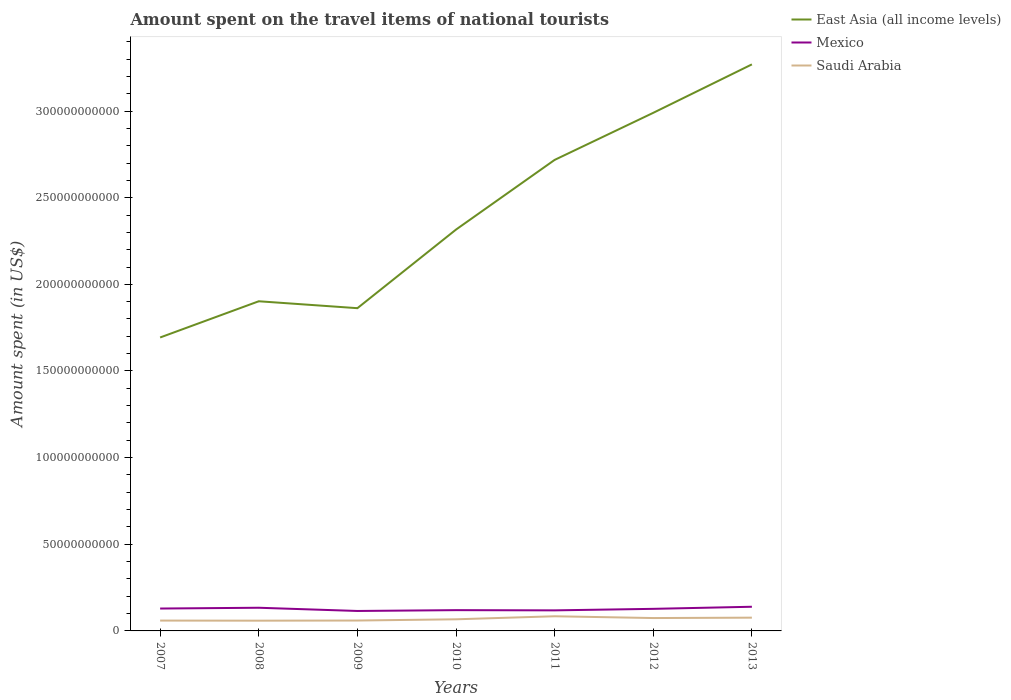How many different coloured lines are there?
Make the answer very short. 3. Across all years, what is the maximum amount spent on the travel items of national tourists in Saudi Arabia?
Offer a very short reply. 5.91e+09. In which year was the amount spent on the travel items of national tourists in East Asia (all income levels) maximum?
Provide a short and direct response. 2007. What is the total amount spent on the travel items of national tourists in Saudi Arabia in the graph?
Make the answer very short. 1.03e+09. What is the difference between the highest and the second highest amount spent on the travel items of national tourists in East Asia (all income levels)?
Ensure brevity in your answer.  1.58e+11. Is the amount spent on the travel items of national tourists in Saudi Arabia strictly greater than the amount spent on the travel items of national tourists in East Asia (all income levels) over the years?
Offer a terse response. Yes. How many lines are there?
Your response must be concise. 3. Where does the legend appear in the graph?
Your response must be concise. Top right. How many legend labels are there?
Ensure brevity in your answer.  3. How are the legend labels stacked?
Your answer should be compact. Vertical. What is the title of the graph?
Give a very brief answer. Amount spent on the travel items of national tourists. Does "Zimbabwe" appear as one of the legend labels in the graph?
Offer a very short reply. No. What is the label or title of the X-axis?
Your answer should be compact. Years. What is the label or title of the Y-axis?
Offer a terse response. Amount spent (in US$). What is the Amount spent (in US$) in East Asia (all income levels) in 2007?
Keep it short and to the point. 1.69e+11. What is the Amount spent (in US$) in Mexico in 2007?
Provide a succinct answer. 1.29e+1. What is the Amount spent (in US$) of Saudi Arabia in 2007?
Make the answer very short. 5.97e+09. What is the Amount spent (in US$) of East Asia (all income levels) in 2008?
Make the answer very short. 1.90e+11. What is the Amount spent (in US$) of Mexico in 2008?
Your answer should be very brief. 1.34e+1. What is the Amount spent (in US$) of Saudi Arabia in 2008?
Your response must be concise. 5.91e+09. What is the Amount spent (in US$) in East Asia (all income levels) in 2009?
Offer a very short reply. 1.86e+11. What is the Amount spent (in US$) of Mexico in 2009?
Make the answer very short. 1.15e+1. What is the Amount spent (in US$) of Saudi Arabia in 2009?
Provide a short and direct response. 6.00e+09. What is the Amount spent (in US$) of East Asia (all income levels) in 2010?
Your response must be concise. 2.32e+11. What is the Amount spent (in US$) of Mexico in 2010?
Your answer should be compact. 1.20e+1. What is the Amount spent (in US$) of Saudi Arabia in 2010?
Make the answer very short. 6.71e+09. What is the Amount spent (in US$) in East Asia (all income levels) in 2011?
Offer a very short reply. 2.72e+11. What is the Amount spent (in US$) in Mexico in 2011?
Give a very brief answer. 1.19e+1. What is the Amount spent (in US$) in Saudi Arabia in 2011?
Ensure brevity in your answer.  8.46e+09. What is the Amount spent (in US$) in East Asia (all income levels) in 2012?
Offer a very short reply. 2.99e+11. What is the Amount spent (in US$) of Mexico in 2012?
Your response must be concise. 1.27e+1. What is the Amount spent (in US$) of Saudi Arabia in 2012?
Ensure brevity in your answer.  7.43e+09. What is the Amount spent (in US$) of East Asia (all income levels) in 2013?
Provide a short and direct response. 3.27e+11. What is the Amount spent (in US$) of Mexico in 2013?
Your answer should be compact. 1.39e+1. What is the Amount spent (in US$) in Saudi Arabia in 2013?
Keep it short and to the point. 7.65e+09. Across all years, what is the maximum Amount spent (in US$) of East Asia (all income levels)?
Ensure brevity in your answer.  3.27e+11. Across all years, what is the maximum Amount spent (in US$) of Mexico?
Offer a terse response. 1.39e+1. Across all years, what is the maximum Amount spent (in US$) in Saudi Arabia?
Your answer should be compact. 8.46e+09. Across all years, what is the minimum Amount spent (in US$) of East Asia (all income levels)?
Make the answer very short. 1.69e+11. Across all years, what is the minimum Amount spent (in US$) of Mexico?
Give a very brief answer. 1.15e+1. Across all years, what is the minimum Amount spent (in US$) of Saudi Arabia?
Provide a succinct answer. 5.91e+09. What is the total Amount spent (in US$) in East Asia (all income levels) in the graph?
Offer a terse response. 1.68e+12. What is the total Amount spent (in US$) of Mexico in the graph?
Provide a succinct answer. 8.84e+1. What is the total Amount spent (in US$) of Saudi Arabia in the graph?
Offer a terse response. 4.81e+1. What is the difference between the Amount spent (in US$) of East Asia (all income levels) in 2007 and that in 2008?
Keep it short and to the point. -2.09e+1. What is the difference between the Amount spent (in US$) in Mexico in 2007 and that in 2008?
Provide a succinct answer. -4.51e+08. What is the difference between the Amount spent (in US$) of Saudi Arabia in 2007 and that in 2008?
Give a very brief answer. 6.10e+07. What is the difference between the Amount spent (in US$) of East Asia (all income levels) in 2007 and that in 2009?
Offer a very short reply. -1.69e+1. What is the difference between the Amount spent (in US$) of Mexico in 2007 and that in 2009?
Provide a short and direct response. 1.41e+09. What is the difference between the Amount spent (in US$) in Saudi Arabia in 2007 and that in 2009?
Offer a terse response. -2.40e+07. What is the difference between the Amount spent (in US$) of East Asia (all income levels) in 2007 and that in 2010?
Make the answer very short. -6.23e+1. What is the difference between the Amount spent (in US$) in Mexico in 2007 and that in 2010?
Ensure brevity in your answer.  9.27e+08. What is the difference between the Amount spent (in US$) in Saudi Arabia in 2007 and that in 2010?
Your answer should be compact. -7.41e+08. What is the difference between the Amount spent (in US$) in East Asia (all income levels) in 2007 and that in 2011?
Give a very brief answer. -1.02e+11. What is the difference between the Amount spent (in US$) in Mexico in 2007 and that in 2011?
Provide a succinct answer. 1.05e+09. What is the difference between the Amount spent (in US$) in Saudi Arabia in 2007 and that in 2011?
Your answer should be very brief. -2.49e+09. What is the difference between the Amount spent (in US$) of East Asia (all income levels) in 2007 and that in 2012?
Your answer should be very brief. -1.30e+11. What is the difference between the Amount spent (in US$) of Mexico in 2007 and that in 2012?
Give a very brief answer. 1.80e+08. What is the difference between the Amount spent (in US$) of Saudi Arabia in 2007 and that in 2012?
Offer a terse response. -1.46e+09. What is the difference between the Amount spent (in US$) of East Asia (all income levels) in 2007 and that in 2013?
Ensure brevity in your answer.  -1.58e+11. What is the difference between the Amount spent (in US$) of Mexico in 2007 and that in 2013?
Make the answer very short. -1.03e+09. What is the difference between the Amount spent (in US$) in Saudi Arabia in 2007 and that in 2013?
Make the answer very short. -1.68e+09. What is the difference between the Amount spent (in US$) of East Asia (all income levels) in 2008 and that in 2009?
Offer a terse response. 3.99e+09. What is the difference between the Amount spent (in US$) of Mexico in 2008 and that in 2009?
Make the answer very short. 1.86e+09. What is the difference between the Amount spent (in US$) in Saudi Arabia in 2008 and that in 2009?
Offer a very short reply. -8.50e+07. What is the difference between the Amount spent (in US$) in East Asia (all income levels) in 2008 and that in 2010?
Your answer should be compact. -4.14e+1. What is the difference between the Amount spent (in US$) in Mexico in 2008 and that in 2010?
Offer a terse response. 1.38e+09. What is the difference between the Amount spent (in US$) in Saudi Arabia in 2008 and that in 2010?
Provide a short and direct response. -8.02e+08. What is the difference between the Amount spent (in US$) of East Asia (all income levels) in 2008 and that in 2011?
Your response must be concise. -8.16e+1. What is the difference between the Amount spent (in US$) of Mexico in 2008 and that in 2011?
Give a very brief answer. 1.50e+09. What is the difference between the Amount spent (in US$) of Saudi Arabia in 2008 and that in 2011?
Offer a very short reply. -2.55e+09. What is the difference between the Amount spent (in US$) of East Asia (all income levels) in 2008 and that in 2012?
Offer a very short reply. -1.09e+11. What is the difference between the Amount spent (in US$) in Mexico in 2008 and that in 2012?
Keep it short and to the point. 6.31e+08. What is the difference between the Amount spent (in US$) in Saudi Arabia in 2008 and that in 2012?
Your response must be concise. -1.52e+09. What is the difference between the Amount spent (in US$) in East Asia (all income levels) in 2008 and that in 2013?
Make the answer very short. -1.37e+11. What is the difference between the Amount spent (in US$) in Mexico in 2008 and that in 2013?
Provide a short and direct response. -5.79e+08. What is the difference between the Amount spent (in US$) in Saudi Arabia in 2008 and that in 2013?
Your answer should be very brief. -1.74e+09. What is the difference between the Amount spent (in US$) in East Asia (all income levels) in 2009 and that in 2010?
Make the answer very short. -4.54e+1. What is the difference between the Amount spent (in US$) in Mexico in 2009 and that in 2010?
Make the answer very short. -4.79e+08. What is the difference between the Amount spent (in US$) of Saudi Arabia in 2009 and that in 2010?
Ensure brevity in your answer.  -7.17e+08. What is the difference between the Amount spent (in US$) of East Asia (all income levels) in 2009 and that in 2011?
Provide a succinct answer. -8.56e+1. What is the difference between the Amount spent (in US$) of Mexico in 2009 and that in 2011?
Keep it short and to the point. -3.56e+08. What is the difference between the Amount spent (in US$) of Saudi Arabia in 2009 and that in 2011?
Provide a short and direct response. -2.46e+09. What is the difference between the Amount spent (in US$) in East Asia (all income levels) in 2009 and that in 2012?
Provide a short and direct response. -1.13e+11. What is the difference between the Amount spent (in US$) in Mexico in 2009 and that in 2012?
Offer a terse response. -1.23e+09. What is the difference between the Amount spent (in US$) in Saudi Arabia in 2009 and that in 2012?
Ensure brevity in your answer.  -1.44e+09. What is the difference between the Amount spent (in US$) in East Asia (all income levels) in 2009 and that in 2013?
Offer a very short reply. -1.41e+11. What is the difference between the Amount spent (in US$) in Mexico in 2009 and that in 2013?
Ensure brevity in your answer.  -2.44e+09. What is the difference between the Amount spent (in US$) of Saudi Arabia in 2009 and that in 2013?
Ensure brevity in your answer.  -1.66e+09. What is the difference between the Amount spent (in US$) of East Asia (all income levels) in 2010 and that in 2011?
Provide a succinct answer. -4.02e+1. What is the difference between the Amount spent (in US$) of Mexico in 2010 and that in 2011?
Your answer should be very brief. 1.23e+08. What is the difference between the Amount spent (in US$) of Saudi Arabia in 2010 and that in 2011?
Provide a short and direct response. -1.75e+09. What is the difference between the Amount spent (in US$) in East Asia (all income levels) in 2010 and that in 2012?
Offer a very short reply. -6.74e+1. What is the difference between the Amount spent (in US$) in Mexico in 2010 and that in 2012?
Provide a succinct answer. -7.47e+08. What is the difference between the Amount spent (in US$) in Saudi Arabia in 2010 and that in 2012?
Your response must be concise. -7.20e+08. What is the difference between the Amount spent (in US$) of East Asia (all income levels) in 2010 and that in 2013?
Provide a short and direct response. -9.53e+1. What is the difference between the Amount spent (in US$) in Mexico in 2010 and that in 2013?
Make the answer very short. -1.96e+09. What is the difference between the Amount spent (in US$) in Saudi Arabia in 2010 and that in 2013?
Make the answer very short. -9.39e+08. What is the difference between the Amount spent (in US$) of East Asia (all income levels) in 2011 and that in 2012?
Offer a very short reply. -2.72e+1. What is the difference between the Amount spent (in US$) of Mexico in 2011 and that in 2012?
Provide a succinct answer. -8.70e+08. What is the difference between the Amount spent (in US$) in Saudi Arabia in 2011 and that in 2012?
Your response must be concise. 1.03e+09. What is the difference between the Amount spent (in US$) in East Asia (all income levels) in 2011 and that in 2013?
Ensure brevity in your answer.  -5.51e+1. What is the difference between the Amount spent (in US$) of Mexico in 2011 and that in 2013?
Ensure brevity in your answer.  -2.08e+09. What is the difference between the Amount spent (in US$) in Saudi Arabia in 2011 and that in 2013?
Your response must be concise. 8.08e+08. What is the difference between the Amount spent (in US$) of East Asia (all income levels) in 2012 and that in 2013?
Your answer should be compact. -2.79e+1. What is the difference between the Amount spent (in US$) in Mexico in 2012 and that in 2013?
Offer a terse response. -1.21e+09. What is the difference between the Amount spent (in US$) of Saudi Arabia in 2012 and that in 2013?
Your response must be concise. -2.19e+08. What is the difference between the Amount spent (in US$) in East Asia (all income levels) in 2007 and the Amount spent (in US$) in Mexico in 2008?
Make the answer very short. 1.56e+11. What is the difference between the Amount spent (in US$) in East Asia (all income levels) in 2007 and the Amount spent (in US$) in Saudi Arabia in 2008?
Keep it short and to the point. 1.63e+11. What is the difference between the Amount spent (in US$) of Mexico in 2007 and the Amount spent (in US$) of Saudi Arabia in 2008?
Ensure brevity in your answer.  7.01e+09. What is the difference between the Amount spent (in US$) in East Asia (all income levels) in 2007 and the Amount spent (in US$) in Mexico in 2009?
Your answer should be compact. 1.58e+11. What is the difference between the Amount spent (in US$) in East Asia (all income levels) in 2007 and the Amount spent (in US$) in Saudi Arabia in 2009?
Keep it short and to the point. 1.63e+11. What is the difference between the Amount spent (in US$) in Mexico in 2007 and the Amount spent (in US$) in Saudi Arabia in 2009?
Your answer should be very brief. 6.92e+09. What is the difference between the Amount spent (in US$) in East Asia (all income levels) in 2007 and the Amount spent (in US$) in Mexico in 2010?
Your answer should be very brief. 1.57e+11. What is the difference between the Amount spent (in US$) in East Asia (all income levels) in 2007 and the Amount spent (in US$) in Saudi Arabia in 2010?
Give a very brief answer. 1.63e+11. What is the difference between the Amount spent (in US$) in Mexico in 2007 and the Amount spent (in US$) in Saudi Arabia in 2010?
Give a very brief answer. 6.21e+09. What is the difference between the Amount spent (in US$) in East Asia (all income levels) in 2007 and the Amount spent (in US$) in Mexico in 2011?
Offer a terse response. 1.57e+11. What is the difference between the Amount spent (in US$) in East Asia (all income levels) in 2007 and the Amount spent (in US$) in Saudi Arabia in 2011?
Your answer should be very brief. 1.61e+11. What is the difference between the Amount spent (in US$) in Mexico in 2007 and the Amount spent (in US$) in Saudi Arabia in 2011?
Make the answer very short. 4.46e+09. What is the difference between the Amount spent (in US$) in East Asia (all income levels) in 2007 and the Amount spent (in US$) in Mexico in 2012?
Your answer should be very brief. 1.57e+11. What is the difference between the Amount spent (in US$) in East Asia (all income levels) in 2007 and the Amount spent (in US$) in Saudi Arabia in 2012?
Make the answer very short. 1.62e+11. What is the difference between the Amount spent (in US$) of Mexico in 2007 and the Amount spent (in US$) of Saudi Arabia in 2012?
Your response must be concise. 5.49e+09. What is the difference between the Amount spent (in US$) in East Asia (all income levels) in 2007 and the Amount spent (in US$) in Mexico in 2013?
Offer a very short reply. 1.55e+11. What is the difference between the Amount spent (in US$) of East Asia (all income levels) in 2007 and the Amount spent (in US$) of Saudi Arabia in 2013?
Your answer should be very brief. 1.62e+11. What is the difference between the Amount spent (in US$) of Mexico in 2007 and the Amount spent (in US$) of Saudi Arabia in 2013?
Keep it short and to the point. 5.27e+09. What is the difference between the Amount spent (in US$) of East Asia (all income levels) in 2008 and the Amount spent (in US$) of Mexico in 2009?
Give a very brief answer. 1.79e+11. What is the difference between the Amount spent (in US$) of East Asia (all income levels) in 2008 and the Amount spent (in US$) of Saudi Arabia in 2009?
Your answer should be compact. 1.84e+11. What is the difference between the Amount spent (in US$) of Mexico in 2008 and the Amount spent (in US$) of Saudi Arabia in 2009?
Keep it short and to the point. 7.38e+09. What is the difference between the Amount spent (in US$) in East Asia (all income levels) in 2008 and the Amount spent (in US$) in Mexico in 2010?
Offer a very short reply. 1.78e+11. What is the difference between the Amount spent (in US$) in East Asia (all income levels) in 2008 and the Amount spent (in US$) in Saudi Arabia in 2010?
Make the answer very short. 1.84e+11. What is the difference between the Amount spent (in US$) in Mexico in 2008 and the Amount spent (in US$) in Saudi Arabia in 2010?
Offer a terse response. 6.66e+09. What is the difference between the Amount spent (in US$) of East Asia (all income levels) in 2008 and the Amount spent (in US$) of Mexico in 2011?
Ensure brevity in your answer.  1.78e+11. What is the difference between the Amount spent (in US$) in East Asia (all income levels) in 2008 and the Amount spent (in US$) in Saudi Arabia in 2011?
Make the answer very short. 1.82e+11. What is the difference between the Amount spent (in US$) of Mexico in 2008 and the Amount spent (in US$) of Saudi Arabia in 2011?
Give a very brief answer. 4.91e+09. What is the difference between the Amount spent (in US$) of East Asia (all income levels) in 2008 and the Amount spent (in US$) of Mexico in 2012?
Make the answer very short. 1.77e+11. What is the difference between the Amount spent (in US$) in East Asia (all income levels) in 2008 and the Amount spent (in US$) in Saudi Arabia in 2012?
Offer a very short reply. 1.83e+11. What is the difference between the Amount spent (in US$) in Mexico in 2008 and the Amount spent (in US$) in Saudi Arabia in 2012?
Keep it short and to the point. 5.94e+09. What is the difference between the Amount spent (in US$) in East Asia (all income levels) in 2008 and the Amount spent (in US$) in Mexico in 2013?
Your answer should be very brief. 1.76e+11. What is the difference between the Amount spent (in US$) of East Asia (all income levels) in 2008 and the Amount spent (in US$) of Saudi Arabia in 2013?
Make the answer very short. 1.83e+11. What is the difference between the Amount spent (in US$) in Mexico in 2008 and the Amount spent (in US$) in Saudi Arabia in 2013?
Keep it short and to the point. 5.72e+09. What is the difference between the Amount spent (in US$) of East Asia (all income levels) in 2009 and the Amount spent (in US$) of Mexico in 2010?
Give a very brief answer. 1.74e+11. What is the difference between the Amount spent (in US$) in East Asia (all income levels) in 2009 and the Amount spent (in US$) in Saudi Arabia in 2010?
Offer a terse response. 1.80e+11. What is the difference between the Amount spent (in US$) of Mexico in 2009 and the Amount spent (in US$) of Saudi Arabia in 2010?
Keep it short and to the point. 4.80e+09. What is the difference between the Amount spent (in US$) in East Asia (all income levels) in 2009 and the Amount spent (in US$) in Mexico in 2011?
Ensure brevity in your answer.  1.74e+11. What is the difference between the Amount spent (in US$) of East Asia (all income levels) in 2009 and the Amount spent (in US$) of Saudi Arabia in 2011?
Ensure brevity in your answer.  1.78e+11. What is the difference between the Amount spent (in US$) in Mexico in 2009 and the Amount spent (in US$) in Saudi Arabia in 2011?
Your response must be concise. 3.05e+09. What is the difference between the Amount spent (in US$) of East Asia (all income levels) in 2009 and the Amount spent (in US$) of Mexico in 2012?
Offer a very short reply. 1.74e+11. What is the difference between the Amount spent (in US$) in East Asia (all income levels) in 2009 and the Amount spent (in US$) in Saudi Arabia in 2012?
Offer a terse response. 1.79e+11. What is the difference between the Amount spent (in US$) of Mexico in 2009 and the Amount spent (in US$) of Saudi Arabia in 2012?
Provide a succinct answer. 4.08e+09. What is the difference between the Amount spent (in US$) of East Asia (all income levels) in 2009 and the Amount spent (in US$) of Mexico in 2013?
Offer a terse response. 1.72e+11. What is the difference between the Amount spent (in US$) of East Asia (all income levels) in 2009 and the Amount spent (in US$) of Saudi Arabia in 2013?
Offer a terse response. 1.79e+11. What is the difference between the Amount spent (in US$) of Mexico in 2009 and the Amount spent (in US$) of Saudi Arabia in 2013?
Give a very brief answer. 3.86e+09. What is the difference between the Amount spent (in US$) of East Asia (all income levels) in 2010 and the Amount spent (in US$) of Mexico in 2011?
Provide a succinct answer. 2.20e+11. What is the difference between the Amount spent (in US$) of East Asia (all income levels) in 2010 and the Amount spent (in US$) of Saudi Arabia in 2011?
Keep it short and to the point. 2.23e+11. What is the difference between the Amount spent (in US$) in Mexico in 2010 and the Amount spent (in US$) in Saudi Arabia in 2011?
Your answer should be compact. 3.53e+09. What is the difference between the Amount spent (in US$) in East Asia (all income levels) in 2010 and the Amount spent (in US$) in Mexico in 2012?
Provide a short and direct response. 2.19e+11. What is the difference between the Amount spent (in US$) of East Asia (all income levels) in 2010 and the Amount spent (in US$) of Saudi Arabia in 2012?
Make the answer very short. 2.24e+11. What is the difference between the Amount spent (in US$) in Mexico in 2010 and the Amount spent (in US$) in Saudi Arabia in 2012?
Your answer should be very brief. 4.56e+09. What is the difference between the Amount spent (in US$) of East Asia (all income levels) in 2010 and the Amount spent (in US$) of Mexico in 2013?
Offer a terse response. 2.18e+11. What is the difference between the Amount spent (in US$) of East Asia (all income levels) in 2010 and the Amount spent (in US$) of Saudi Arabia in 2013?
Make the answer very short. 2.24e+11. What is the difference between the Amount spent (in US$) of Mexico in 2010 and the Amount spent (in US$) of Saudi Arabia in 2013?
Give a very brief answer. 4.34e+09. What is the difference between the Amount spent (in US$) in East Asia (all income levels) in 2011 and the Amount spent (in US$) in Mexico in 2012?
Your response must be concise. 2.59e+11. What is the difference between the Amount spent (in US$) in East Asia (all income levels) in 2011 and the Amount spent (in US$) in Saudi Arabia in 2012?
Give a very brief answer. 2.64e+11. What is the difference between the Amount spent (in US$) in Mexico in 2011 and the Amount spent (in US$) in Saudi Arabia in 2012?
Your answer should be compact. 4.44e+09. What is the difference between the Amount spent (in US$) of East Asia (all income levels) in 2011 and the Amount spent (in US$) of Mexico in 2013?
Make the answer very short. 2.58e+11. What is the difference between the Amount spent (in US$) of East Asia (all income levels) in 2011 and the Amount spent (in US$) of Saudi Arabia in 2013?
Provide a short and direct response. 2.64e+11. What is the difference between the Amount spent (in US$) in Mexico in 2011 and the Amount spent (in US$) in Saudi Arabia in 2013?
Make the answer very short. 4.22e+09. What is the difference between the Amount spent (in US$) of East Asia (all income levels) in 2012 and the Amount spent (in US$) of Mexico in 2013?
Ensure brevity in your answer.  2.85e+11. What is the difference between the Amount spent (in US$) of East Asia (all income levels) in 2012 and the Amount spent (in US$) of Saudi Arabia in 2013?
Your answer should be very brief. 2.91e+11. What is the difference between the Amount spent (in US$) in Mexico in 2012 and the Amount spent (in US$) in Saudi Arabia in 2013?
Provide a succinct answer. 5.09e+09. What is the average Amount spent (in US$) of East Asia (all income levels) per year?
Offer a very short reply. 2.39e+11. What is the average Amount spent (in US$) of Mexico per year?
Your response must be concise. 1.26e+1. What is the average Amount spent (in US$) of Saudi Arabia per year?
Ensure brevity in your answer.  6.88e+09. In the year 2007, what is the difference between the Amount spent (in US$) of East Asia (all income levels) and Amount spent (in US$) of Mexico?
Make the answer very short. 1.56e+11. In the year 2007, what is the difference between the Amount spent (in US$) of East Asia (all income levels) and Amount spent (in US$) of Saudi Arabia?
Keep it short and to the point. 1.63e+11. In the year 2007, what is the difference between the Amount spent (in US$) in Mexico and Amount spent (in US$) in Saudi Arabia?
Give a very brief answer. 6.95e+09. In the year 2008, what is the difference between the Amount spent (in US$) of East Asia (all income levels) and Amount spent (in US$) of Mexico?
Your response must be concise. 1.77e+11. In the year 2008, what is the difference between the Amount spent (in US$) of East Asia (all income levels) and Amount spent (in US$) of Saudi Arabia?
Your answer should be compact. 1.84e+11. In the year 2008, what is the difference between the Amount spent (in US$) in Mexico and Amount spent (in US$) in Saudi Arabia?
Make the answer very short. 7.46e+09. In the year 2009, what is the difference between the Amount spent (in US$) of East Asia (all income levels) and Amount spent (in US$) of Mexico?
Offer a terse response. 1.75e+11. In the year 2009, what is the difference between the Amount spent (in US$) in East Asia (all income levels) and Amount spent (in US$) in Saudi Arabia?
Your response must be concise. 1.80e+11. In the year 2009, what is the difference between the Amount spent (in US$) in Mexico and Amount spent (in US$) in Saudi Arabia?
Provide a short and direct response. 5.52e+09. In the year 2010, what is the difference between the Amount spent (in US$) in East Asia (all income levels) and Amount spent (in US$) in Mexico?
Make the answer very short. 2.20e+11. In the year 2010, what is the difference between the Amount spent (in US$) in East Asia (all income levels) and Amount spent (in US$) in Saudi Arabia?
Provide a short and direct response. 2.25e+11. In the year 2010, what is the difference between the Amount spent (in US$) of Mexico and Amount spent (in US$) of Saudi Arabia?
Your answer should be very brief. 5.28e+09. In the year 2011, what is the difference between the Amount spent (in US$) of East Asia (all income levels) and Amount spent (in US$) of Mexico?
Ensure brevity in your answer.  2.60e+11. In the year 2011, what is the difference between the Amount spent (in US$) of East Asia (all income levels) and Amount spent (in US$) of Saudi Arabia?
Offer a very short reply. 2.63e+11. In the year 2011, what is the difference between the Amount spent (in US$) in Mexico and Amount spent (in US$) in Saudi Arabia?
Provide a short and direct response. 3.41e+09. In the year 2012, what is the difference between the Amount spent (in US$) in East Asia (all income levels) and Amount spent (in US$) in Mexico?
Provide a succinct answer. 2.86e+11. In the year 2012, what is the difference between the Amount spent (in US$) in East Asia (all income levels) and Amount spent (in US$) in Saudi Arabia?
Your answer should be very brief. 2.92e+11. In the year 2012, what is the difference between the Amount spent (in US$) of Mexico and Amount spent (in US$) of Saudi Arabia?
Your response must be concise. 5.31e+09. In the year 2013, what is the difference between the Amount spent (in US$) of East Asia (all income levels) and Amount spent (in US$) of Mexico?
Your answer should be compact. 3.13e+11. In the year 2013, what is the difference between the Amount spent (in US$) in East Asia (all income levels) and Amount spent (in US$) in Saudi Arabia?
Give a very brief answer. 3.19e+11. In the year 2013, what is the difference between the Amount spent (in US$) of Mexico and Amount spent (in US$) of Saudi Arabia?
Ensure brevity in your answer.  6.30e+09. What is the ratio of the Amount spent (in US$) of East Asia (all income levels) in 2007 to that in 2008?
Ensure brevity in your answer.  0.89. What is the ratio of the Amount spent (in US$) in Mexico in 2007 to that in 2008?
Your response must be concise. 0.97. What is the ratio of the Amount spent (in US$) of Saudi Arabia in 2007 to that in 2008?
Your response must be concise. 1.01. What is the ratio of the Amount spent (in US$) of East Asia (all income levels) in 2007 to that in 2009?
Make the answer very short. 0.91. What is the ratio of the Amount spent (in US$) of Mexico in 2007 to that in 2009?
Make the answer very short. 1.12. What is the ratio of the Amount spent (in US$) in East Asia (all income levels) in 2007 to that in 2010?
Offer a very short reply. 0.73. What is the ratio of the Amount spent (in US$) in Mexico in 2007 to that in 2010?
Give a very brief answer. 1.08. What is the ratio of the Amount spent (in US$) in Saudi Arabia in 2007 to that in 2010?
Make the answer very short. 0.89. What is the ratio of the Amount spent (in US$) of East Asia (all income levels) in 2007 to that in 2011?
Provide a short and direct response. 0.62. What is the ratio of the Amount spent (in US$) of Mexico in 2007 to that in 2011?
Make the answer very short. 1.09. What is the ratio of the Amount spent (in US$) of Saudi Arabia in 2007 to that in 2011?
Provide a succinct answer. 0.71. What is the ratio of the Amount spent (in US$) of East Asia (all income levels) in 2007 to that in 2012?
Give a very brief answer. 0.57. What is the ratio of the Amount spent (in US$) of Mexico in 2007 to that in 2012?
Give a very brief answer. 1.01. What is the ratio of the Amount spent (in US$) of Saudi Arabia in 2007 to that in 2012?
Ensure brevity in your answer.  0.8. What is the ratio of the Amount spent (in US$) of East Asia (all income levels) in 2007 to that in 2013?
Make the answer very short. 0.52. What is the ratio of the Amount spent (in US$) of Mexico in 2007 to that in 2013?
Ensure brevity in your answer.  0.93. What is the ratio of the Amount spent (in US$) of Saudi Arabia in 2007 to that in 2013?
Ensure brevity in your answer.  0.78. What is the ratio of the Amount spent (in US$) in East Asia (all income levels) in 2008 to that in 2009?
Give a very brief answer. 1.02. What is the ratio of the Amount spent (in US$) of Mexico in 2008 to that in 2009?
Your answer should be very brief. 1.16. What is the ratio of the Amount spent (in US$) of Saudi Arabia in 2008 to that in 2009?
Give a very brief answer. 0.99. What is the ratio of the Amount spent (in US$) in East Asia (all income levels) in 2008 to that in 2010?
Make the answer very short. 0.82. What is the ratio of the Amount spent (in US$) of Mexico in 2008 to that in 2010?
Give a very brief answer. 1.11. What is the ratio of the Amount spent (in US$) in Saudi Arabia in 2008 to that in 2010?
Make the answer very short. 0.88. What is the ratio of the Amount spent (in US$) of East Asia (all income levels) in 2008 to that in 2011?
Offer a terse response. 0.7. What is the ratio of the Amount spent (in US$) of Mexico in 2008 to that in 2011?
Give a very brief answer. 1.13. What is the ratio of the Amount spent (in US$) in Saudi Arabia in 2008 to that in 2011?
Your answer should be very brief. 0.7. What is the ratio of the Amount spent (in US$) in East Asia (all income levels) in 2008 to that in 2012?
Offer a very short reply. 0.64. What is the ratio of the Amount spent (in US$) in Mexico in 2008 to that in 2012?
Offer a terse response. 1.05. What is the ratio of the Amount spent (in US$) in Saudi Arabia in 2008 to that in 2012?
Your answer should be compact. 0.8. What is the ratio of the Amount spent (in US$) of East Asia (all income levels) in 2008 to that in 2013?
Your response must be concise. 0.58. What is the ratio of the Amount spent (in US$) in Mexico in 2008 to that in 2013?
Keep it short and to the point. 0.96. What is the ratio of the Amount spent (in US$) in Saudi Arabia in 2008 to that in 2013?
Your answer should be very brief. 0.77. What is the ratio of the Amount spent (in US$) of East Asia (all income levels) in 2009 to that in 2010?
Provide a succinct answer. 0.8. What is the ratio of the Amount spent (in US$) in Mexico in 2009 to that in 2010?
Offer a terse response. 0.96. What is the ratio of the Amount spent (in US$) of Saudi Arabia in 2009 to that in 2010?
Give a very brief answer. 0.89. What is the ratio of the Amount spent (in US$) in East Asia (all income levels) in 2009 to that in 2011?
Make the answer very short. 0.69. What is the ratio of the Amount spent (in US$) in Mexico in 2009 to that in 2011?
Keep it short and to the point. 0.97. What is the ratio of the Amount spent (in US$) of Saudi Arabia in 2009 to that in 2011?
Your response must be concise. 0.71. What is the ratio of the Amount spent (in US$) of East Asia (all income levels) in 2009 to that in 2012?
Your answer should be compact. 0.62. What is the ratio of the Amount spent (in US$) of Mexico in 2009 to that in 2012?
Your answer should be compact. 0.9. What is the ratio of the Amount spent (in US$) in Saudi Arabia in 2009 to that in 2012?
Provide a short and direct response. 0.81. What is the ratio of the Amount spent (in US$) in East Asia (all income levels) in 2009 to that in 2013?
Provide a short and direct response. 0.57. What is the ratio of the Amount spent (in US$) in Mexico in 2009 to that in 2013?
Give a very brief answer. 0.83. What is the ratio of the Amount spent (in US$) in Saudi Arabia in 2009 to that in 2013?
Offer a terse response. 0.78. What is the ratio of the Amount spent (in US$) of East Asia (all income levels) in 2010 to that in 2011?
Give a very brief answer. 0.85. What is the ratio of the Amount spent (in US$) of Mexico in 2010 to that in 2011?
Give a very brief answer. 1.01. What is the ratio of the Amount spent (in US$) of Saudi Arabia in 2010 to that in 2011?
Your answer should be compact. 0.79. What is the ratio of the Amount spent (in US$) of East Asia (all income levels) in 2010 to that in 2012?
Provide a succinct answer. 0.77. What is the ratio of the Amount spent (in US$) in Mexico in 2010 to that in 2012?
Your answer should be very brief. 0.94. What is the ratio of the Amount spent (in US$) in Saudi Arabia in 2010 to that in 2012?
Make the answer very short. 0.9. What is the ratio of the Amount spent (in US$) of East Asia (all income levels) in 2010 to that in 2013?
Give a very brief answer. 0.71. What is the ratio of the Amount spent (in US$) of Mexico in 2010 to that in 2013?
Make the answer very short. 0.86. What is the ratio of the Amount spent (in US$) of Saudi Arabia in 2010 to that in 2013?
Ensure brevity in your answer.  0.88. What is the ratio of the Amount spent (in US$) of East Asia (all income levels) in 2011 to that in 2012?
Your answer should be compact. 0.91. What is the ratio of the Amount spent (in US$) of Mexico in 2011 to that in 2012?
Ensure brevity in your answer.  0.93. What is the ratio of the Amount spent (in US$) of Saudi Arabia in 2011 to that in 2012?
Your answer should be very brief. 1.14. What is the ratio of the Amount spent (in US$) in East Asia (all income levels) in 2011 to that in 2013?
Provide a succinct answer. 0.83. What is the ratio of the Amount spent (in US$) in Mexico in 2011 to that in 2013?
Ensure brevity in your answer.  0.85. What is the ratio of the Amount spent (in US$) of Saudi Arabia in 2011 to that in 2013?
Offer a terse response. 1.11. What is the ratio of the Amount spent (in US$) of East Asia (all income levels) in 2012 to that in 2013?
Provide a short and direct response. 0.91. What is the ratio of the Amount spent (in US$) in Mexico in 2012 to that in 2013?
Make the answer very short. 0.91. What is the ratio of the Amount spent (in US$) of Saudi Arabia in 2012 to that in 2013?
Offer a terse response. 0.97. What is the difference between the highest and the second highest Amount spent (in US$) in East Asia (all income levels)?
Your answer should be very brief. 2.79e+1. What is the difference between the highest and the second highest Amount spent (in US$) of Mexico?
Provide a short and direct response. 5.79e+08. What is the difference between the highest and the second highest Amount spent (in US$) of Saudi Arabia?
Provide a short and direct response. 8.08e+08. What is the difference between the highest and the lowest Amount spent (in US$) of East Asia (all income levels)?
Your answer should be compact. 1.58e+11. What is the difference between the highest and the lowest Amount spent (in US$) in Mexico?
Offer a terse response. 2.44e+09. What is the difference between the highest and the lowest Amount spent (in US$) of Saudi Arabia?
Provide a succinct answer. 2.55e+09. 